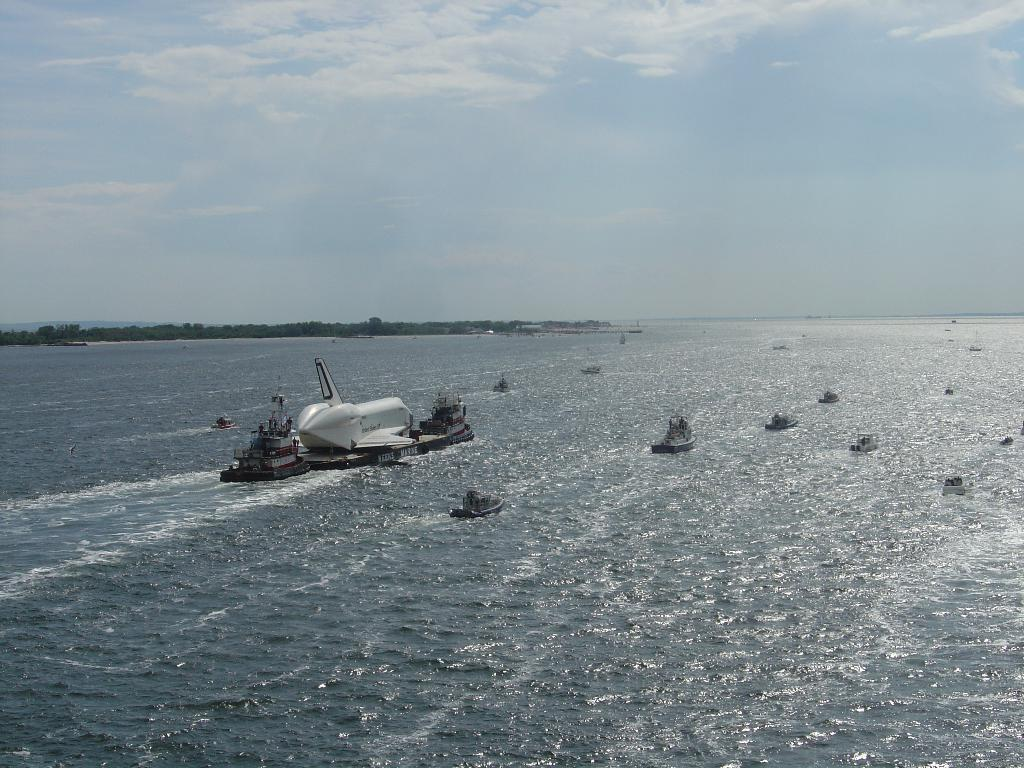What is the main subject of the image? The main subject of the image is ships. Where are the ships located? The ships are on the water. What can be seen in the background of the image? Trees and the sky are visible in the background of the image. What is the condition of the sky in the image? Clouds are present in the sky. What type of animal can be seen playing with the son in the image? There is no animal or son present in the image; it features ships on the water with a background of trees and clouds. 